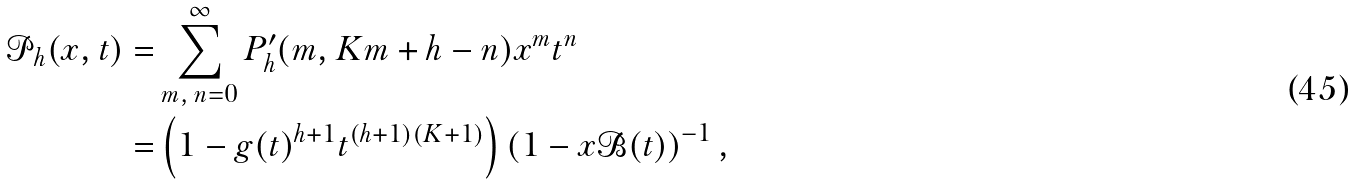<formula> <loc_0><loc_0><loc_500><loc_500>\mathcal { P } _ { h } ( x , t ) = & \sum _ { m , \, n = 0 } ^ { \infty } P ^ { \prime } _ { h } ( m , K m + h - n ) x ^ { m } t ^ { n } \\ = & \left ( 1 - g ( t ) ^ { h + 1 } t ^ { ( h + 1 ) ( K + 1 ) } \right ) \left ( 1 - x \mathcal { B } ( t ) \right ) ^ { - 1 } ,</formula> 